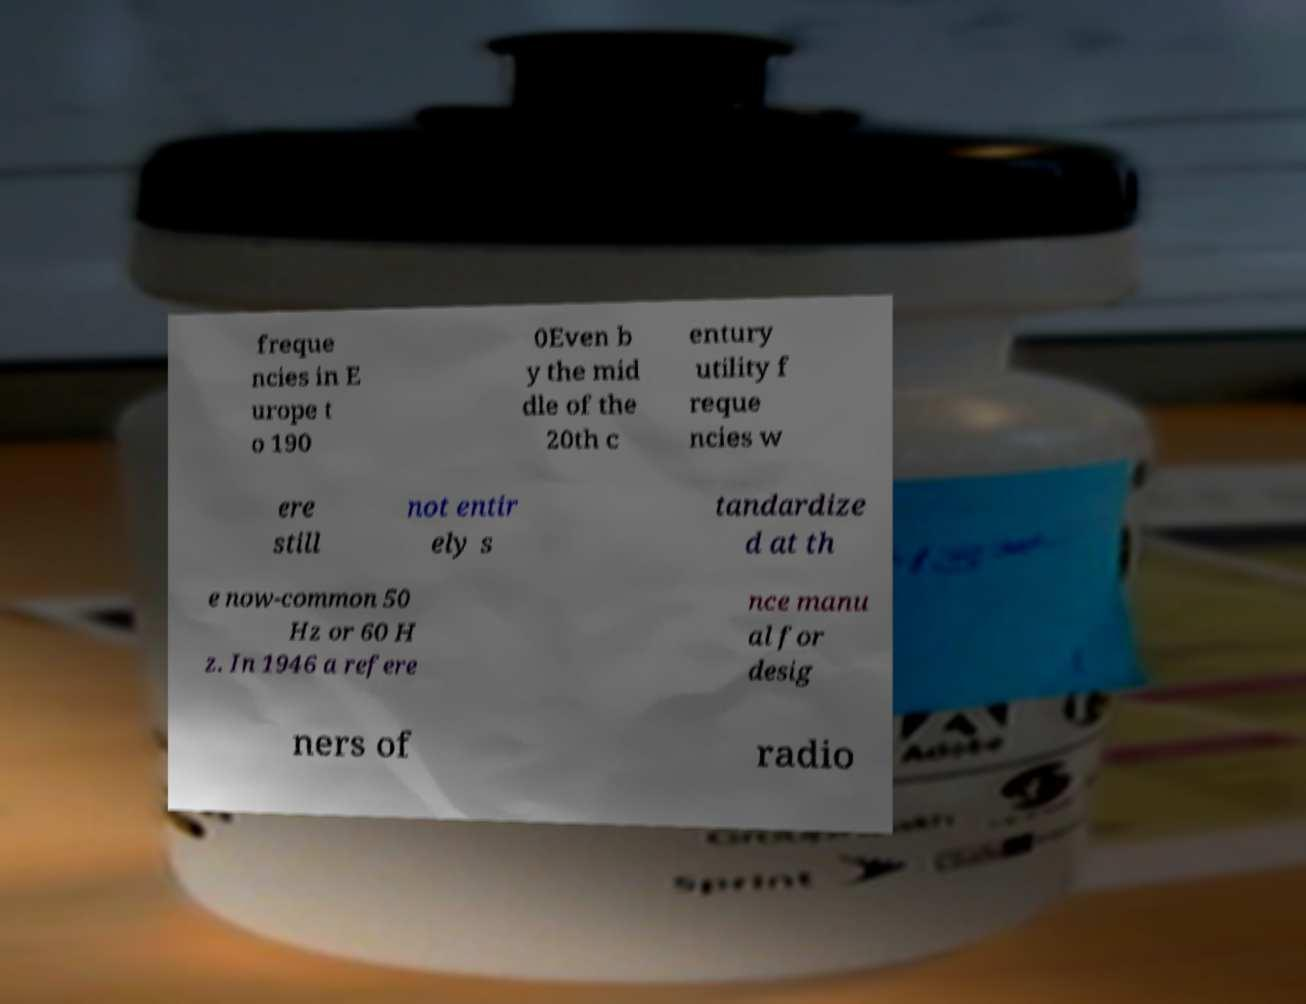Can you read and provide the text displayed in the image?This photo seems to have some interesting text. Can you extract and type it out for me? freque ncies in E urope t o 190 0Even b y the mid dle of the 20th c entury utility f reque ncies w ere still not entir ely s tandardize d at th e now-common 50 Hz or 60 H z. In 1946 a refere nce manu al for desig ners of radio 